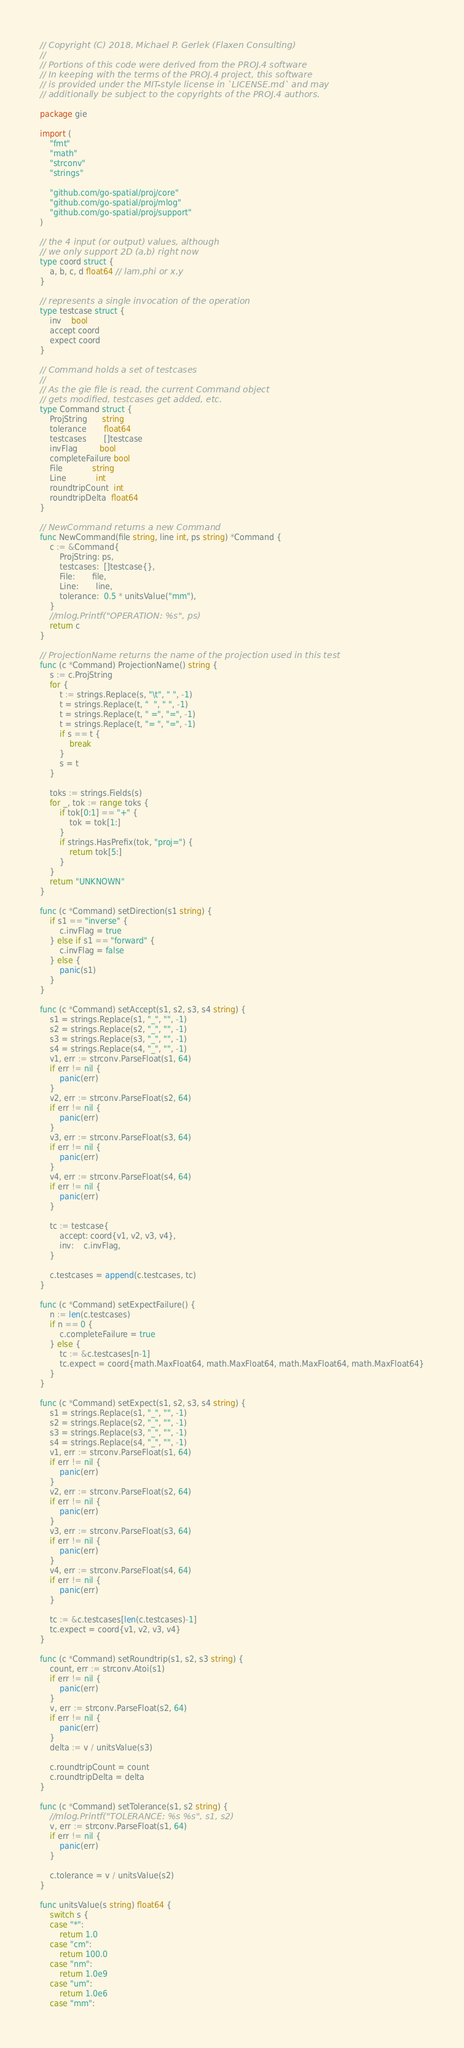Convert code to text. <code><loc_0><loc_0><loc_500><loc_500><_Go_>// Copyright (C) 2018, Michael P. Gerlek (Flaxen Consulting)
//
// Portions of this code were derived from the PROJ.4 software
// In keeping with the terms of the PROJ.4 project, this software
// is provided under the MIT-style license in `LICENSE.md` and may
// additionally be subject to the copyrights of the PROJ.4 authors.

package gie

import (
	"fmt"
	"math"
	"strconv"
	"strings"

	"github.com/go-spatial/proj/core"
	"github.com/go-spatial/proj/mlog"
	"github.com/go-spatial/proj/support"
)

// the 4 input (or output) values, although
// we only support 2D (a,b) right now
type coord struct {
	a, b, c, d float64 // lam,phi or x,y
}

// represents a single invocation of the operation
type testcase struct {
	inv    bool
	accept coord
	expect coord
}

// Command holds a set of testcases
//
// As the gie file is read, the current Command object
// gets modified, testcases get added, etc.
type Command struct {
	ProjString      string
	tolerance       float64
	testcases       []testcase
	invFlag         bool
	completeFailure bool
	File            string
	Line            int
	roundtripCount  int
	roundtripDelta  float64
}

// NewCommand returns a new Command
func NewCommand(file string, line int, ps string) *Command {
	c := &Command{
		ProjString: ps,
		testcases:  []testcase{},
		File:       file,
		Line:       line,
		tolerance:  0.5 * unitsValue("mm"),
	}
	//mlog.Printf("OPERATION: %s", ps)
	return c
}

// ProjectionName returns the name of the projection used in this test
func (c *Command) ProjectionName() string {
	s := c.ProjString
	for {
		t := strings.Replace(s, "\t", " ", -1)
		t = strings.Replace(t, "  ", " ", -1)
		t = strings.Replace(t, " =", "=", -1)
		t = strings.Replace(t, "= ", "=", -1)
		if s == t {
			break
		}
		s = t
	}

	toks := strings.Fields(s)
	for _, tok := range toks {
		if tok[0:1] == "+" {
			tok = tok[1:]
		}
		if strings.HasPrefix(tok, "proj=") {
			return tok[5:]
		}
	}
	return "UNKNOWN"
}

func (c *Command) setDirection(s1 string) {
	if s1 == "inverse" {
		c.invFlag = true
	} else if s1 == "forward" {
		c.invFlag = false
	} else {
		panic(s1)
	}
}

func (c *Command) setAccept(s1, s2, s3, s4 string) {
	s1 = strings.Replace(s1, "_", "", -1)
	s2 = strings.Replace(s2, "_", "", -1)
	s3 = strings.Replace(s3, "_", "", -1)
	s4 = strings.Replace(s4, "_", "", -1)
	v1, err := strconv.ParseFloat(s1, 64)
	if err != nil {
		panic(err)
	}
	v2, err := strconv.ParseFloat(s2, 64)
	if err != nil {
		panic(err)
	}
	v3, err := strconv.ParseFloat(s3, 64)
	if err != nil {
		panic(err)
	}
	v4, err := strconv.ParseFloat(s4, 64)
	if err != nil {
		panic(err)
	}

	tc := testcase{
		accept: coord{v1, v2, v3, v4},
		inv:    c.invFlag,
	}

	c.testcases = append(c.testcases, tc)
}

func (c *Command) setExpectFailure() {
	n := len(c.testcases)
	if n == 0 {
		c.completeFailure = true
	} else {
		tc := &c.testcases[n-1]
		tc.expect = coord{math.MaxFloat64, math.MaxFloat64, math.MaxFloat64, math.MaxFloat64}
	}
}

func (c *Command) setExpect(s1, s2, s3, s4 string) {
	s1 = strings.Replace(s1, "_", "", -1)
	s2 = strings.Replace(s2, "_", "", -1)
	s3 = strings.Replace(s3, "_", "", -1)
	s4 = strings.Replace(s4, "_", "", -1)
	v1, err := strconv.ParseFloat(s1, 64)
	if err != nil {
		panic(err)
	}
	v2, err := strconv.ParseFloat(s2, 64)
	if err != nil {
		panic(err)
	}
	v3, err := strconv.ParseFloat(s3, 64)
	if err != nil {
		panic(err)
	}
	v4, err := strconv.ParseFloat(s4, 64)
	if err != nil {
		panic(err)
	}

	tc := &c.testcases[len(c.testcases)-1]
	tc.expect = coord{v1, v2, v3, v4}
}

func (c *Command) setRoundtrip(s1, s2, s3 string) {
	count, err := strconv.Atoi(s1)
	if err != nil {
		panic(err)
	}
	v, err := strconv.ParseFloat(s2, 64)
	if err != nil {
		panic(err)
	}
	delta := v / unitsValue(s3)

	c.roundtripCount = count
	c.roundtripDelta = delta
}

func (c *Command) setTolerance(s1, s2 string) {
	//mlog.Printf("TOLERANCE: %s %s", s1, s2)
	v, err := strconv.ParseFloat(s1, 64)
	if err != nil {
		panic(err)
	}

	c.tolerance = v / unitsValue(s2)
}

func unitsValue(s string) float64 {
	switch s {
	case "*":
		return 1.0
	case "cm":
		return 100.0
	case "nm":
		return 1.0e9
	case "um":
		return 1.0e6
	case "mm":</code> 